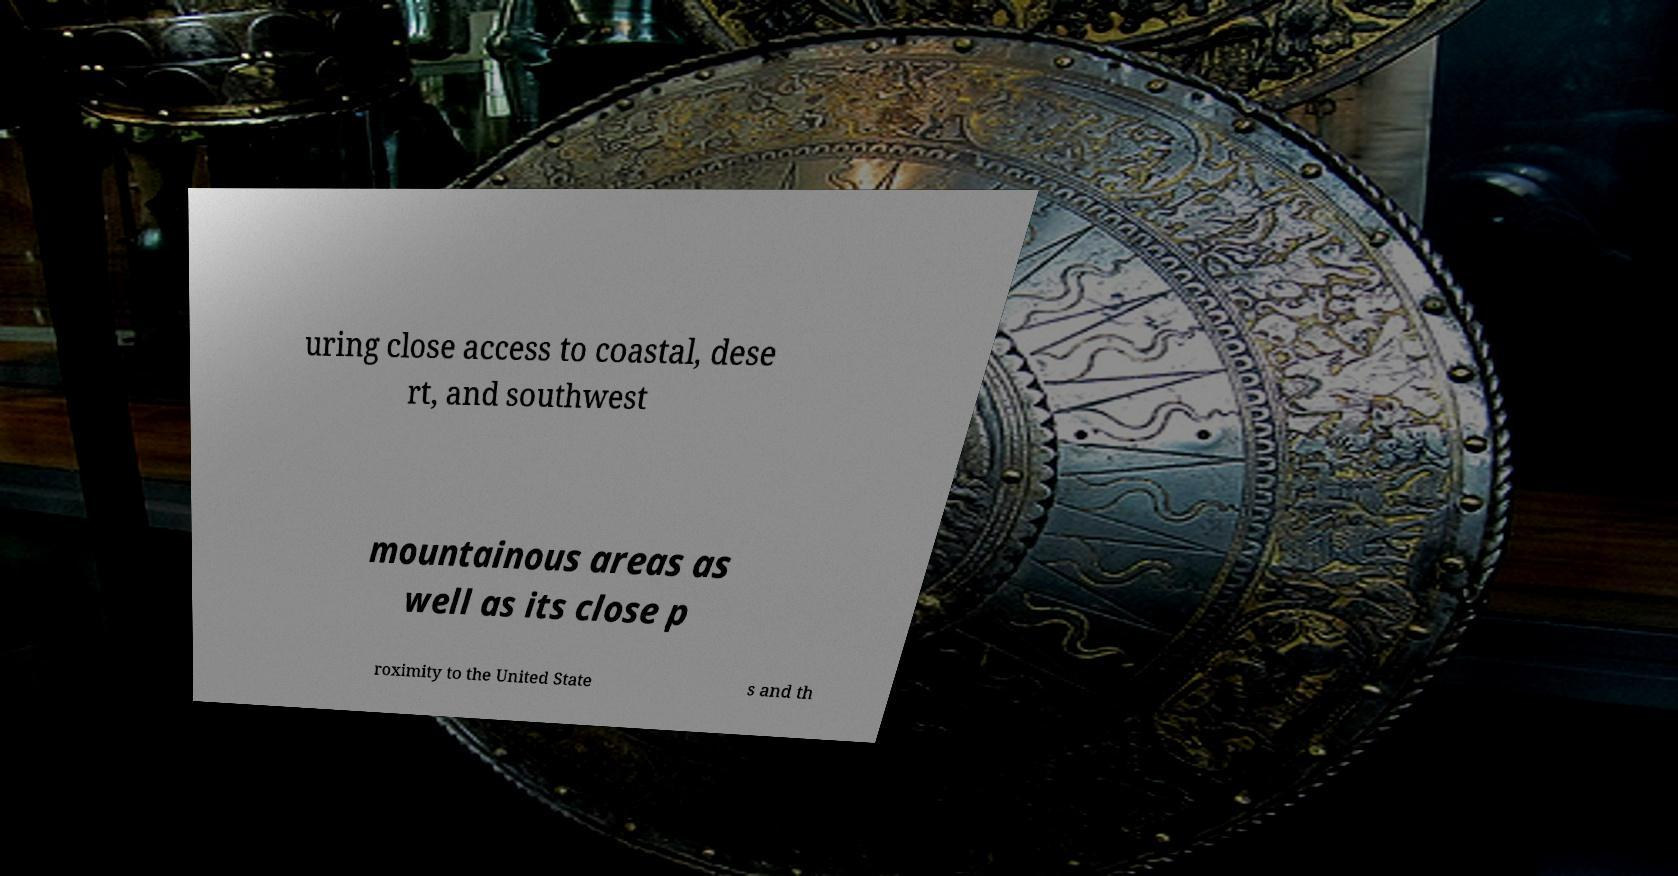Can you accurately transcribe the text from the provided image for me? uring close access to coastal, dese rt, and southwest mountainous areas as well as its close p roximity to the United State s and th 